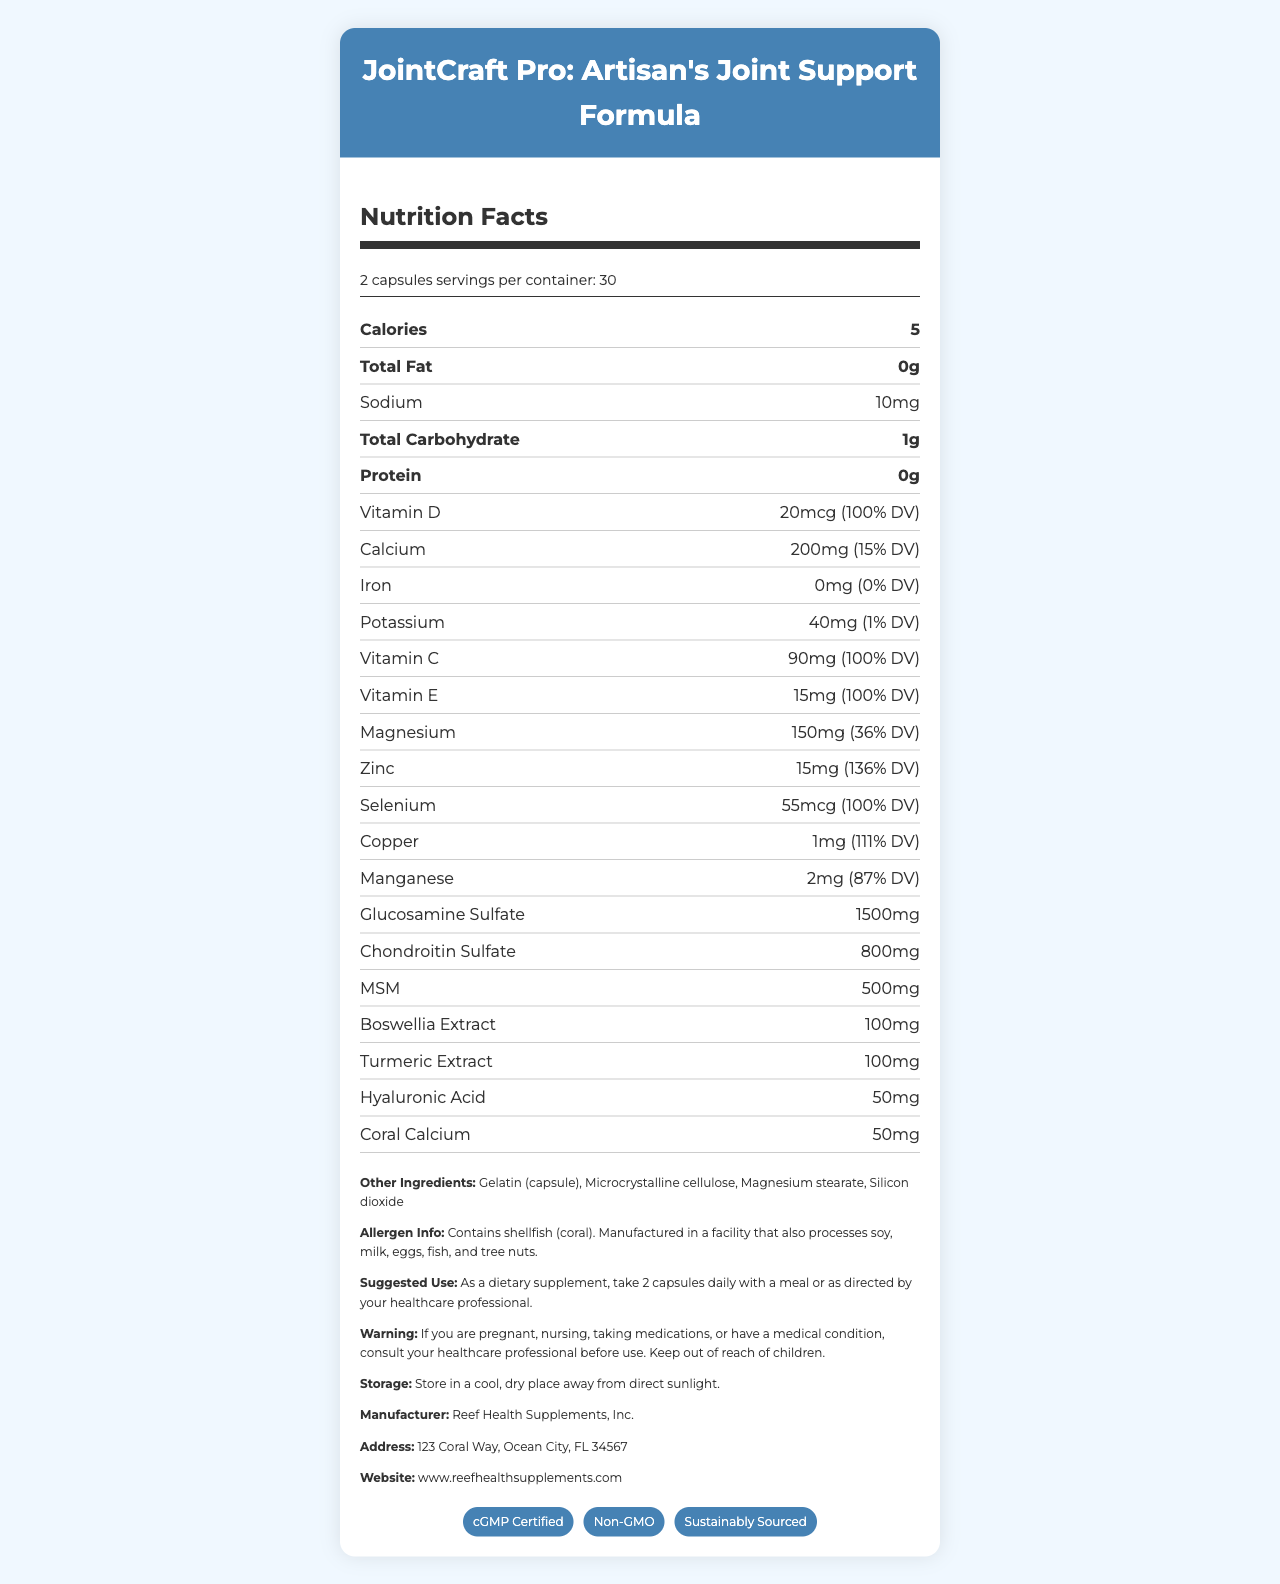what is the serving size for JointCraft Pro? The serving size is indicated as "2 capsules" under the serving information section.
Answer: 2 capsules how much Vitamin D is in one serving? The amount of Vitamin D is listed as "20mcg (100% DV)" in the nutrient rows.
Answer: 20mcg (100% DV) how many calories are in each serving? Under the "Calories" section, it states that there are 5 calories per serving.
Answer: 5 where is the manufacturer located? The address of the manufacturer is found in the additional information section: "123 Coral Way, Ocean City, FL 34567".
Answer: 123 Coral Way, Ocean City, FL 34567 what is the suggested use of this supplement? This information is found under the "Suggested Use" section.
Answer: Take 2 capsules daily with a meal or as directed by your healthcare professional how much calcium does this supplement provide? The amount of calcium is listed as "200mg (15% DV)" in the nutrient rows.
Answer: 200mg (15% DV) what certifications does JointCraft Pro have? A. cGMP Certified B. Non-GMO C. Sustainably Sourced D. All of the above The certifications section lists "cGMP Certified", "Non-GMO", and "Sustainably Sourced".
Answer: D. All of the above which ingredient is responsible for joint health support primarily? A. Vitamin C B. Calcium C. Glucosamine Sulfate D. Hyaluronic Acid The primary joint health support ingredient, as listed in the document, is "Glucosamine Sulfate".
Answer: C. Glucosamine Sulfate is this product suitable for people with shellfish allergies? The allergen information section states that the product contains shellfish (coral).
Answer: No what is the total carbohydrate content per serving? The total carbohydrate content is listed as "1g" under the nutrient rows.
Answer: 1g summarize the key information provided in the document. This summary captures the main points from the product's nutrition facts, ingredients, usage, and certifications.
Answer: JointCraft Pro is a dietary supplement aimed at supporting joint health, especially for those in artisanal professions such as jewelry making. The supplement contains various vitamins, minerals, and compounds specifically beneficial for joint health like Glucosamine Sulfate and Chondroitin Sulfate. It comes in a serving size of 2 capsules with 30 servings per container. Nutritional information includes 5 calories per serving, with notable nutrients provided being Vitamin D, Vitamin C, Calcium, and others. It is cGMP Certified, Non-GMO, and Sustainably Sourced. The manufacturer, Reef Health Supplements, Inc., warns users about potential allergens and provides guidance on the suggested use and storage. how much iron is in each serving? The iron content is listed as "0mg (0% DV)" in the nutrient rows.
Answer: 0mg (0% DV) what additional ingredients are included in JointCraft Pro? The additional ingredients are listed under the "Other Ingredients" section.
Answer: Gelatin (capsule), Microcrystalline cellulose, Magnesium stearate, Silicon dioxide what should you do if you have a medical condition before using this product? The warning section advises users with medical conditions to consult their healthcare professional before use.
Answer: Consult your healthcare professional before use how many capsules should one take daily according to the suggested use? The suggested use section states to take 2 capsules daily.
Answer: 2 capsules how much magnesium does this supplement contain? A. 50mg B. 100mg C. 150mg D. 200mg The magnesium content is listed as "150mg (36% DV)" in the nutrient rows.
Answer: C. 150mg how many servings are there in one container? The serving information notes that there are 30 servings per container.
Answer: 30 is there any information on whether this product is gluten-free? The document does not provide any information regarding whether the product is gluten-free.
Answer: I don't know 